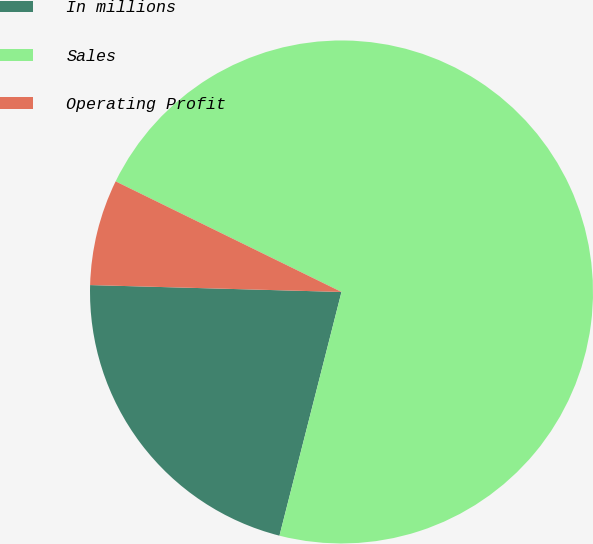Convert chart to OTSL. <chart><loc_0><loc_0><loc_500><loc_500><pie_chart><fcel>In millions<fcel>Sales<fcel>Operating Profit<nl><fcel>21.47%<fcel>71.72%<fcel>6.81%<nl></chart> 